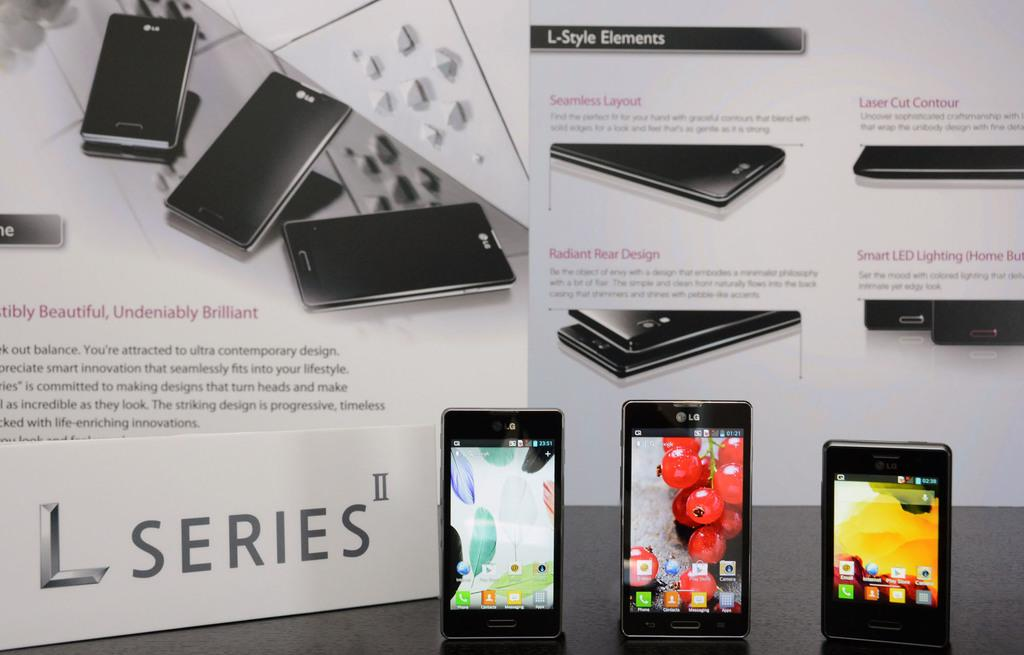<image>
Render a clear and concise summary of the photo. Three different L series branded phones with different background images on them. 